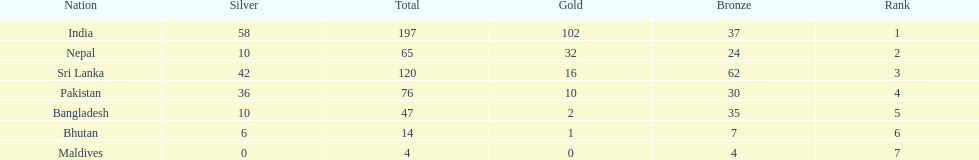How many gold medals did india win? 102. 